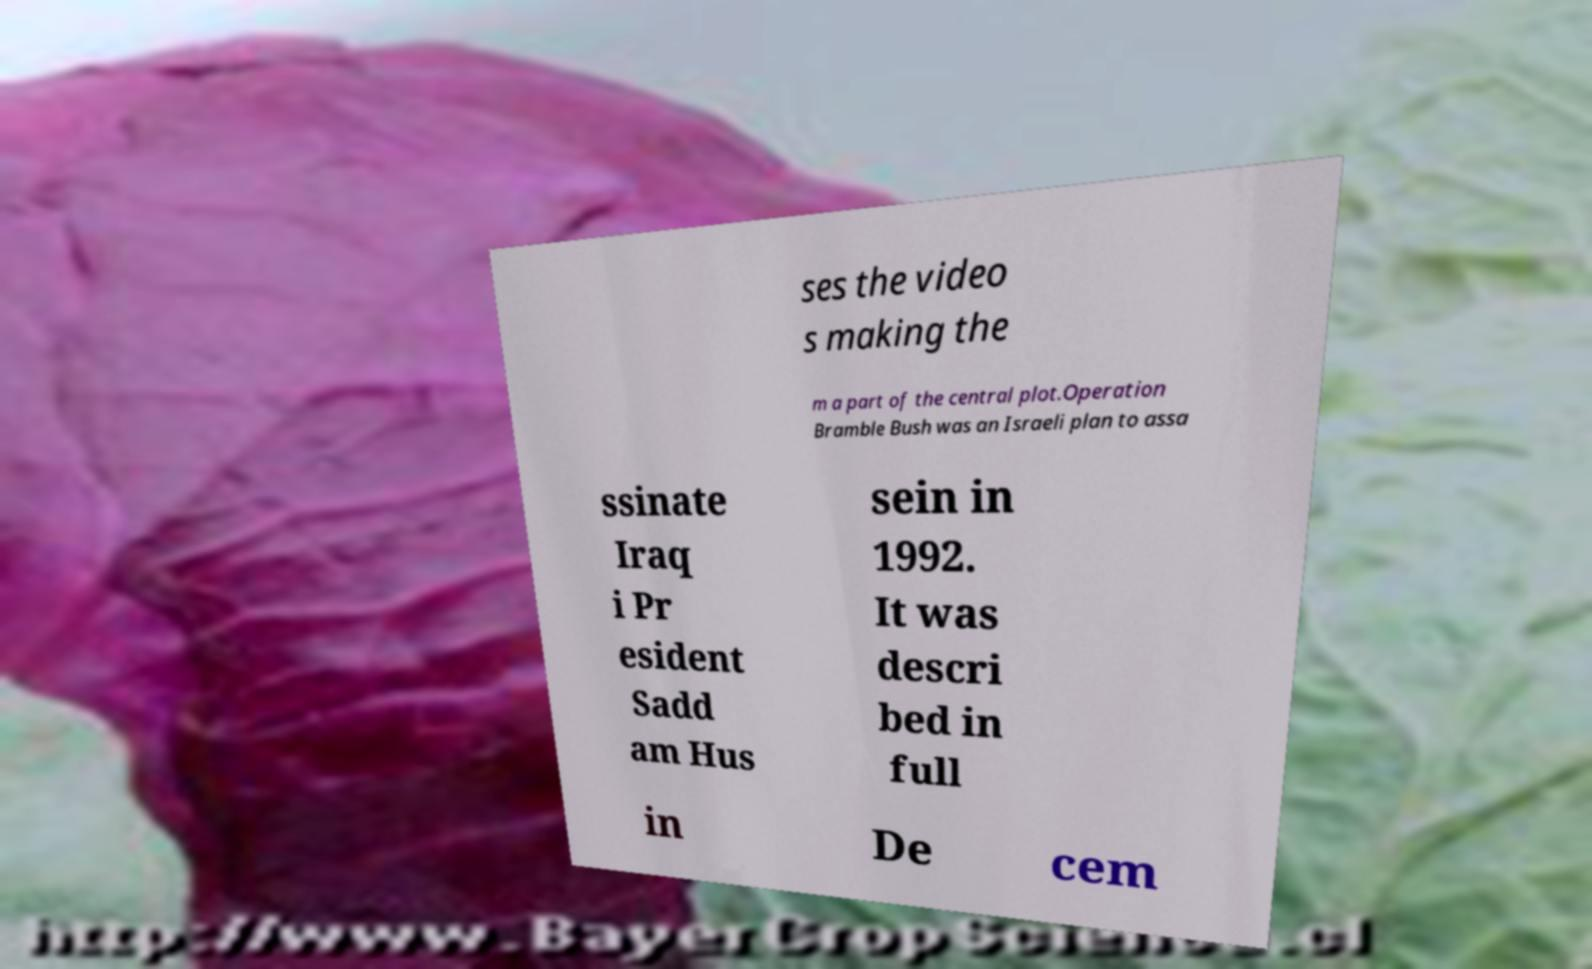Could you assist in decoding the text presented in this image and type it out clearly? ses the video s making the m a part of the central plot.Operation Bramble Bush was an Israeli plan to assa ssinate Iraq i Pr esident Sadd am Hus sein in 1992. It was descri bed in full in De cem 